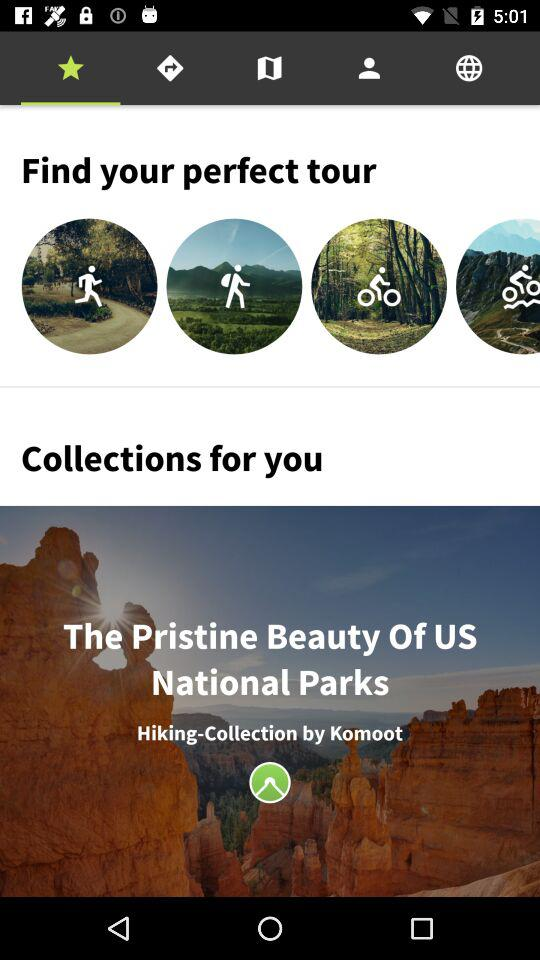By whom are the hiking collections made? Hiking collections are made by "Komoot". 